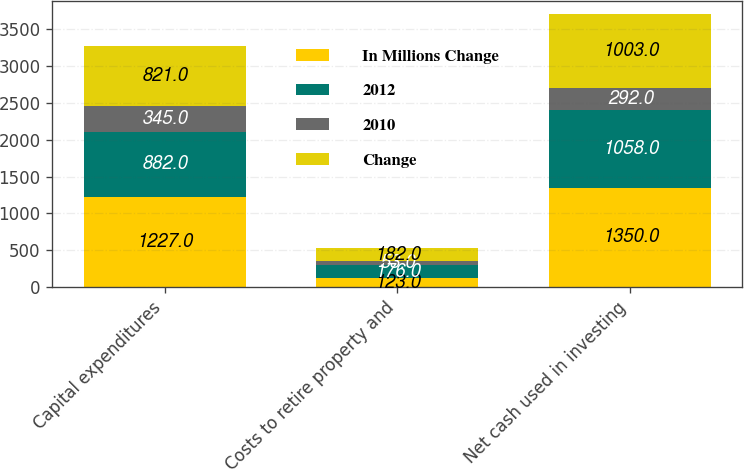<chart> <loc_0><loc_0><loc_500><loc_500><stacked_bar_chart><ecel><fcel>Capital expenditures<fcel>Costs to retire property and<fcel>Net cash used in investing<nl><fcel>In Millions Change<fcel>1227<fcel>123<fcel>1350<nl><fcel>2012<fcel>882<fcel>176<fcel>1058<nl><fcel>2010<fcel>345<fcel>53<fcel>292<nl><fcel>Change<fcel>821<fcel>182<fcel>1003<nl></chart> 